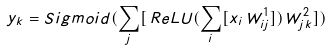Convert formula to latex. <formula><loc_0><loc_0><loc_500><loc_500>y _ { k } = S i g m o i d ( \sum _ { j } [ \, R e L U ( \sum _ { i } [ x _ { i } \, W ^ { 1 } _ { i j } ] ) \, W ^ { 2 } _ { j k } ] )</formula> 